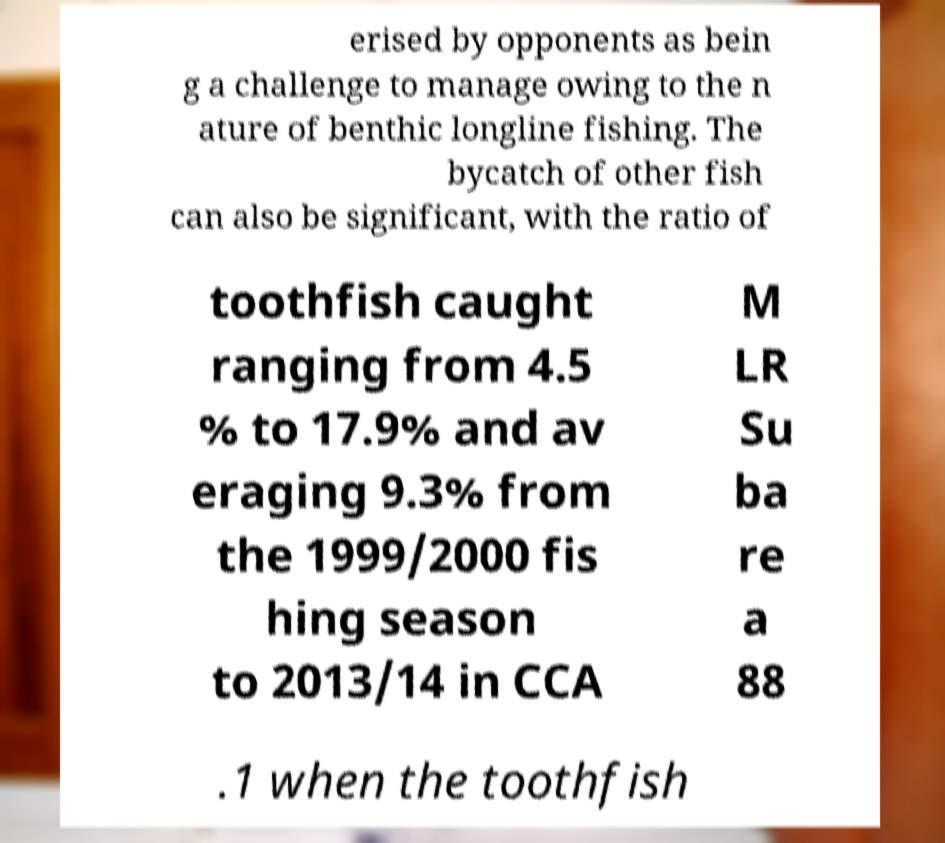There's text embedded in this image that I need extracted. Can you transcribe it verbatim? erised by opponents as bein g a challenge to manage owing to the n ature of benthic longline fishing. The bycatch of other fish can also be significant, with the ratio of toothfish caught ranging from 4.5 % to 17.9% and av eraging 9.3% from the 1999/2000 fis hing season to 2013/14 in CCA M LR Su ba re a 88 .1 when the toothfish 